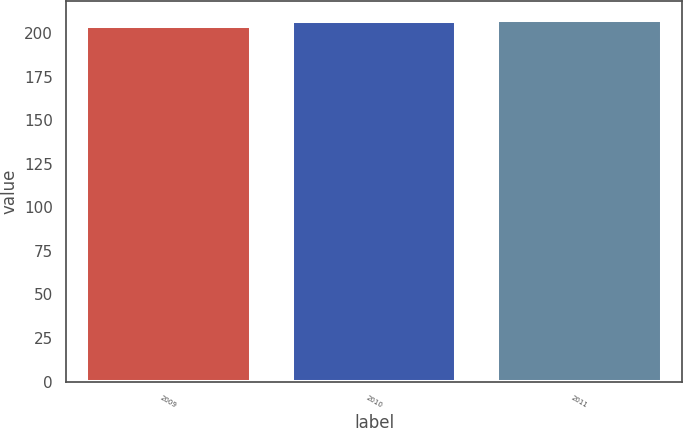Convert chart to OTSL. <chart><loc_0><loc_0><loc_500><loc_500><bar_chart><fcel>2009<fcel>2010<fcel>2011<nl><fcel>204<fcel>207<fcel>208<nl></chart> 